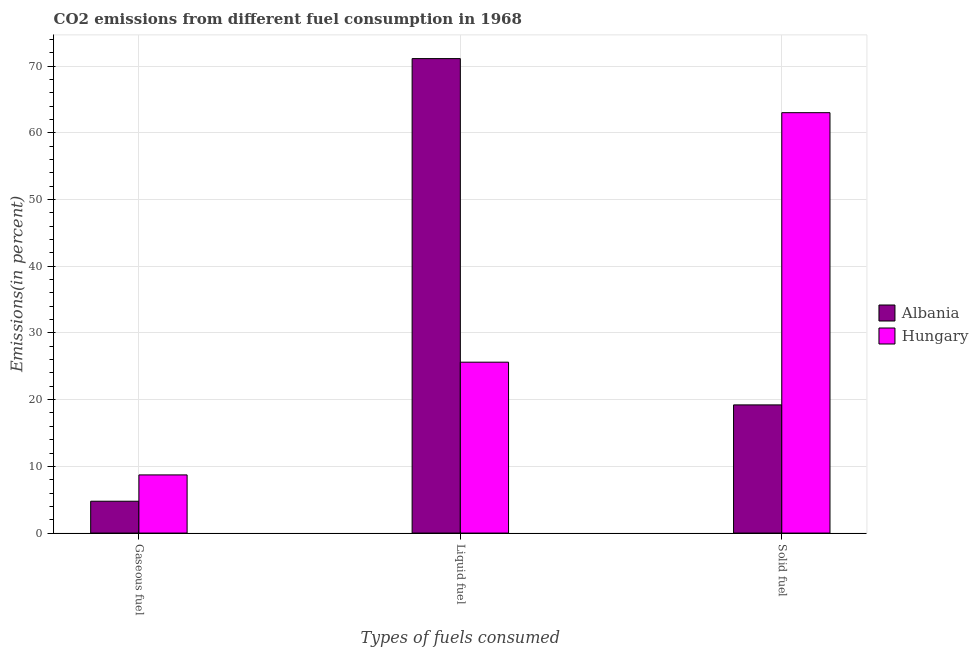How many different coloured bars are there?
Ensure brevity in your answer.  2. How many bars are there on the 2nd tick from the left?
Offer a terse response. 2. How many bars are there on the 3rd tick from the right?
Provide a short and direct response. 2. What is the label of the 1st group of bars from the left?
Provide a succinct answer. Gaseous fuel. What is the percentage of solid fuel emission in Hungary?
Keep it short and to the point. 63.01. Across all countries, what is the maximum percentage of liquid fuel emission?
Your response must be concise. 71.12. Across all countries, what is the minimum percentage of gaseous fuel emission?
Give a very brief answer. 4.77. In which country was the percentage of liquid fuel emission maximum?
Give a very brief answer. Albania. In which country was the percentage of liquid fuel emission minimum?
Provide a succinct answer. Hungary. What is the total percentage of liquid fuel emission in the graph?
Your response must be concise. 96.74. What is the difference between the percentage of gaseous fuel emission in Albania and that in Hungary?
Offer a terse response. -3.95. What is the difference between the percentage of liquid fuel emission in Albania and the percentage of solid fuel emission in Hungary?
Keep it short and to the point. 8.11. What is the average percentage of solid fuel emission per country?
Your answer should be compact. 41.11. What is the difference between the percentage of gaseous fuel emission and percentage of solid fuel emission in Albania?
Provide a succinct answer. -14.44. In how many countries, is the percentage of solid fuel emission greater than 36 %?
Your answer should be compact. 1. What is the ratio of the percentage of liquid fuel emission in Hungary to that in Albania?
Make the answer very short. 0.36. What is the difference between the highest and the second highest percentage of liquid fuel emission?
Provide a succinct answer. 45.51. What is the difference between the highest and the lowest percentage of liquid fuel emission?
Your answer should be very brief. 45.51. Is the sum of the percentage of solid fuel emission in Hungary and Albania greater than the maximum percentage of gaseous fuel emission across all countries?
Your answer should be very brief. Yes. What does the 2nd bar from the left in Liquid fuel represents?
Your response must be concise. Hungary. What does the 1st bar from the right in Gaseous fuel represents?
Provide a succinct answer. Hungary. How many bars are there?
Offer a terse response. 6. How many countries are there in the graph?
Make the answer very short. 2. Does the graph contain any zero values?
Your response must be concise. No. Does the graph contain grids?
Your response must be concise. Yes. Where does the legend appear in the graph?
Ensure brevity in your answer.  Center right. How are the legend labels stacked?
Provide a succinct answer. Vertical. What is the title of the graph?
Provide a succinct answer. CO2 emissions from different fuel consumption in 1968. What is the label or title of the X-axis?
Make the answer very short. Types of fuels consumed. What is the label or title of the Y-axis?
Your response must be concise. Emissions(in percent). What is the Emissions(in percent) of Albania in Gaseous fuel?
Make the answer very short. 4.77. What is the Emissions(in percent) of Hungary in Gaseous fuel?
Your answer should be very brief. 8.72. What is the Emissions(in percent) in Albania in Liquid fuel?
Offer a very short reply. 71.12. What is the Emissions(in percent) in Hungary in Liquid fuel?
Provide a succinct answer. 25.62. What is the Emissions(in percent) of Albania in Solid fuel?
Your answer should be compact. 19.21. What is the Emissions(in percent) of Hungary in Solid fuel?
Your answer should be very brief. 63.01. Across all Types of fuels consumed, what is the maximum Emissions(in percent) in Albania?
Your answer should be compact. 71.12. Across all Types of fuels consumed, what is the maximum Emissions(in percent) of Hungary?
Keep it short and to the point. 63.01. Across all Types of fuels consumed, what is the minimum Emissions(in percent) of Albania?
Keep it short and to the point. 4.77. Across all Types of fuels consumed, what is the minimum Emissions(in percent) in Hungary?
Keep it short and to the point. 8.72. What is the total Emissions(in percent) in Albania in the graph?
Your answer should be compact. 95.11. What is the total Emissions(in percent) in Hungary in the graph?
Keep it short and to the point. 97.35. What is the difference between the Emissions(in percent) in Albania in Gaseous fuel and that in Liquid fuel?
Your answer should be very brief. -66.35. What is the difference between the Emissions(in percent) in Hungary in Gaseous fuel and that in Liquid fuel?
Give a very brief answer. -16.9. What is the difference between the Emissions(in percent) in Albania in Gaseous fuel and that in Solid fuel?
Your answer should be compact. -14.44. What is the difference between the Emissions(in percent) in Hungary in Gaseous fuel and that in Solid fuel?
Ensure brevity in your answer.  -54.3. What is the difference between the Emissions(in percent) of Albania in Liquid fuel and that in Solid fuel?
Your answer should be compact. 51.91. What is the difference between the Emissions(in percent) of Hungary in Liquid fuel and that in Solid fuel?
Your answer should be compact. -37.4. What is the difference between the Emissions(in percent) of Albania in Gaseous fuel and the Emissions(in percent) of Hungary in Liquid fuel?
Ensure brevity in your answer.  -20.84. What is the difference between the Emissions(in percent) in Albania in Gaseous fuel and the Emissions(in percent) in Hungary in Solid fuel?
Make the answer very short. -58.24. What is the difference between the Emissions(in percent) in Albania in Liquid fuel and the Emissions(in percent) in Hungary in Solid fuel?
Give a very brief answer. 8.11. What is the average Emissions(in percent) in Albania per Types of fuels consumed?
Offer a very short reply. 31.7. What is the average Emissions(in percent) in Hungary per Types of fuels consumed?
Your answer should be very brief. 32.45. What is the difference between the Emissions(in percent) in Albania and Emissions(in percent) in Hungary in Gaseous fuel?
Your answer should be very brief. -3.95. What is the difference between the Emissions(in percent) of Albania and Emissions(in percent) of Hungary in Liquid fuel?
Your response must be concise. 45.51. What is the difference between the Emissions(in percent) in Albania and Emissions(in percent) in Hungary in Solid fuel?
Give a very brief answer. -43.8. What is the ratio of the Emissions(in percent) of Albania in Gaseous fuel to that in Liquid fuel?
Offer a very short reply. 0.07. What is the ratio of the Emissions(in percent) of Hungary in Gaseous fuel to that in Liquid fuel?
Offer a terse response. 0.34. What is the ratio of the Emissions(in percent) in Albania in Gaseous fuel to that in Solid fuel?
Your answer should be compact. 0.25. What is the ratio of the Emissions(in percent) in Hungary in Gaseous fuel to that in Solid fuel?
Make the answer very short. 0.14. What is the ratio of the Emissions(in percent) in Albania in Liquid fuel to that in Solid fuel?
Ensure brevity in your answer.  3.7. What is the ratio of the Emissions(in percent) in Hungary in Liquid fuel to that in Solid fuel?
Your answer should be compact. 0.41. What is the difference between the highest and the second highest Emissions(in percent) of Albania?
Provide a short and direct response. 51.91. What is the difference between the highest and the second highest Emissions(in percent) in Hungary?
Your answer should be compact. 37.4. What is the difference between the highest and the lowest Emissions(in percent) of Albania?
Provide a short and direct response. 66.35. What is the difference between the highest and the lowest Emissions(in percent) in Hungary?
Your answer should be very brief. 54.3. 